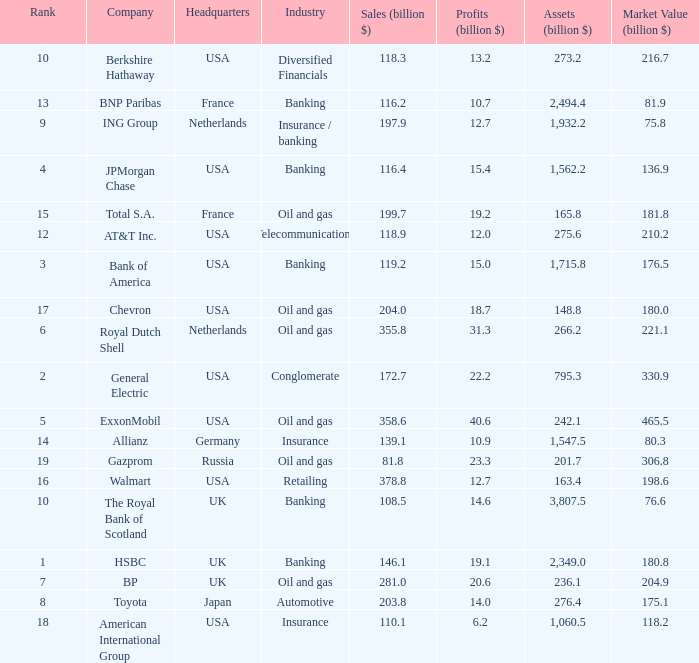9 billion? 20.6. 